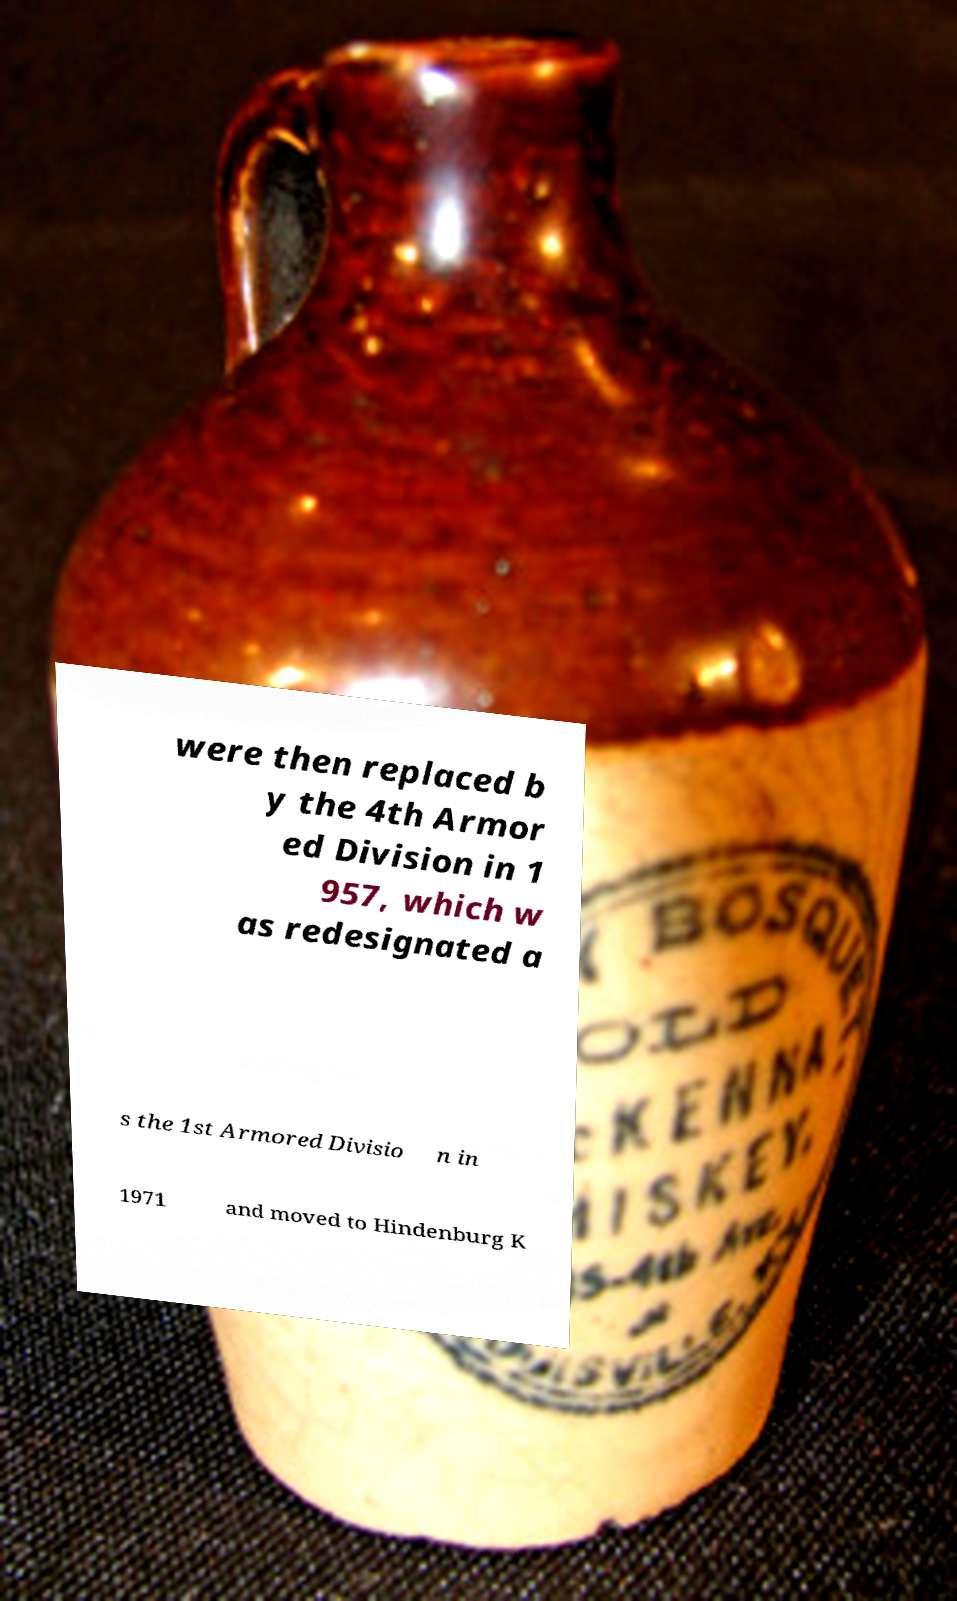What messages or text are displayed in this image? I need them in a readable, typed format. were then replaced b y the 4th Armor ed Division in 1 957, which w as redesignated a s the 1st Armored Divisio n in 1971 and moved to Hindenburg K 